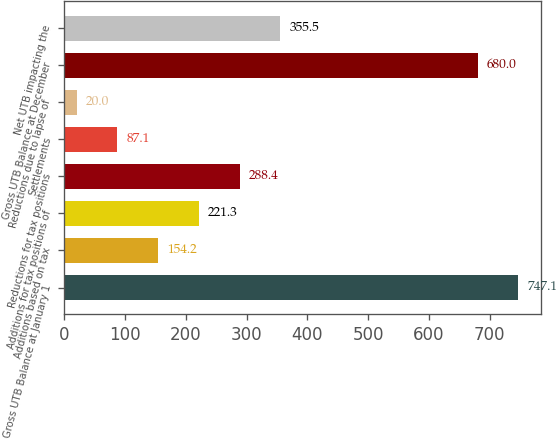<chart> <loc_0><loc_0><loc_500><loc_500><bar_chart><fcel>Gross UTB Balance at January 1<fcel>Additions based on tax<fcel>Additions for tax positions of<fcel>Reductions for tax positions<fcel>Settlements<fcel>Reductions due to lapse of<fcel>Gross UTB Balance at December<fcel>Net UTB impacting the<nl><fcel>747.1<fcel>154.2<fcel>221.3<fcel>288.4<fcel>87.1<fcel>20<fcel>680<fcel>355.5<nl></chart> 